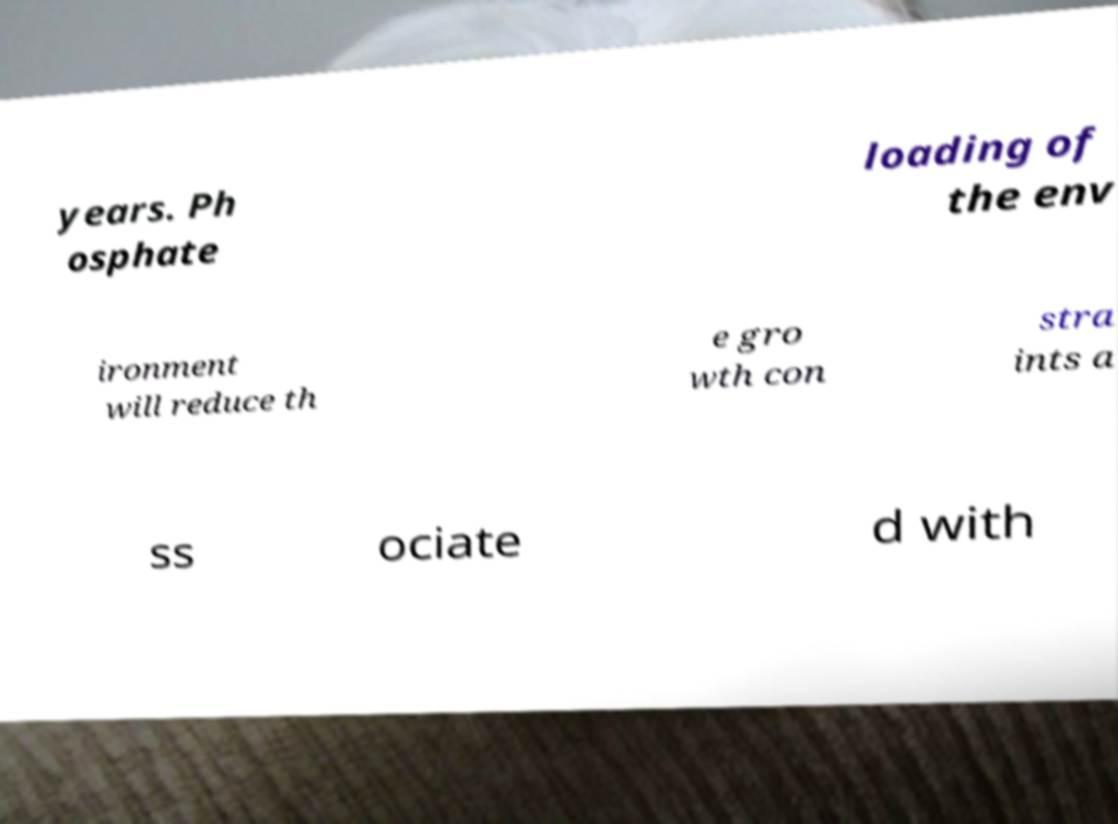Could you extract and type out the text from this image? years. Ph osphate loading of the env ironment will reduce th e gro wth con stra ints a ss ociate d with 